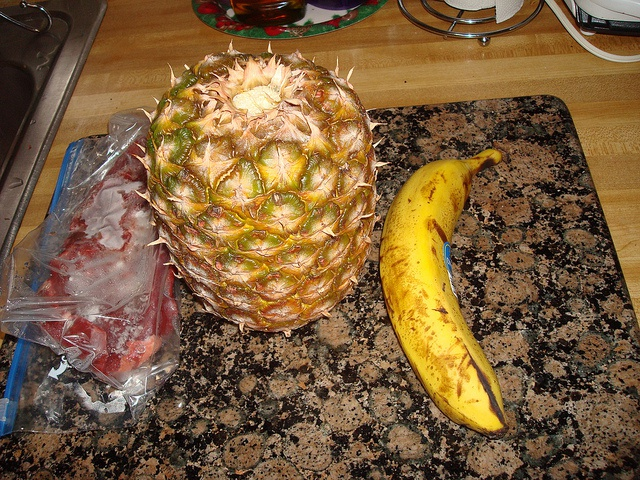Describe the objects in this image and their specific colors. I can see dining table in black, olive, gray, and maroon tones and banana in maroon, orange, gold, and olive tones in this image. 